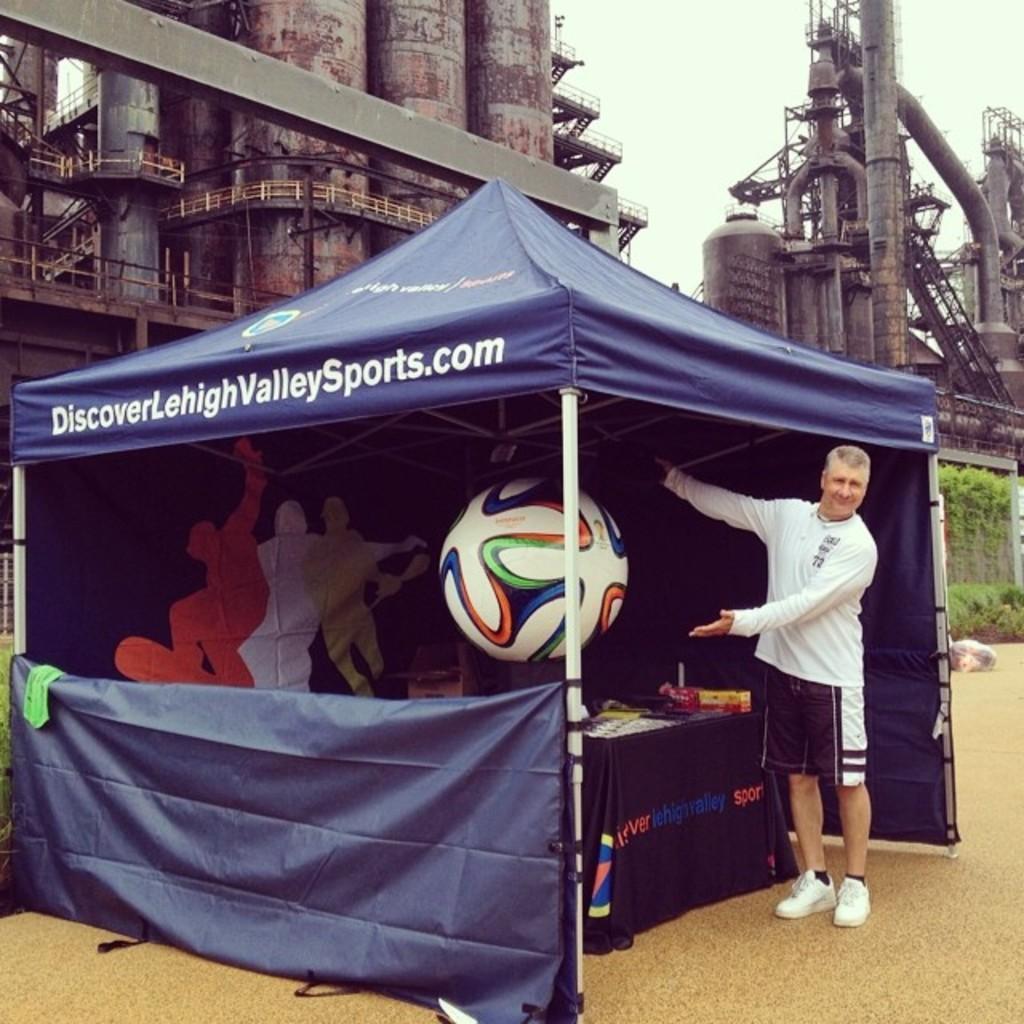Can you describe this image briefly? In this image there is a man standing under the tent. Inside the tent there is a table and some objects were placed on it. At the back side there is a factory. 